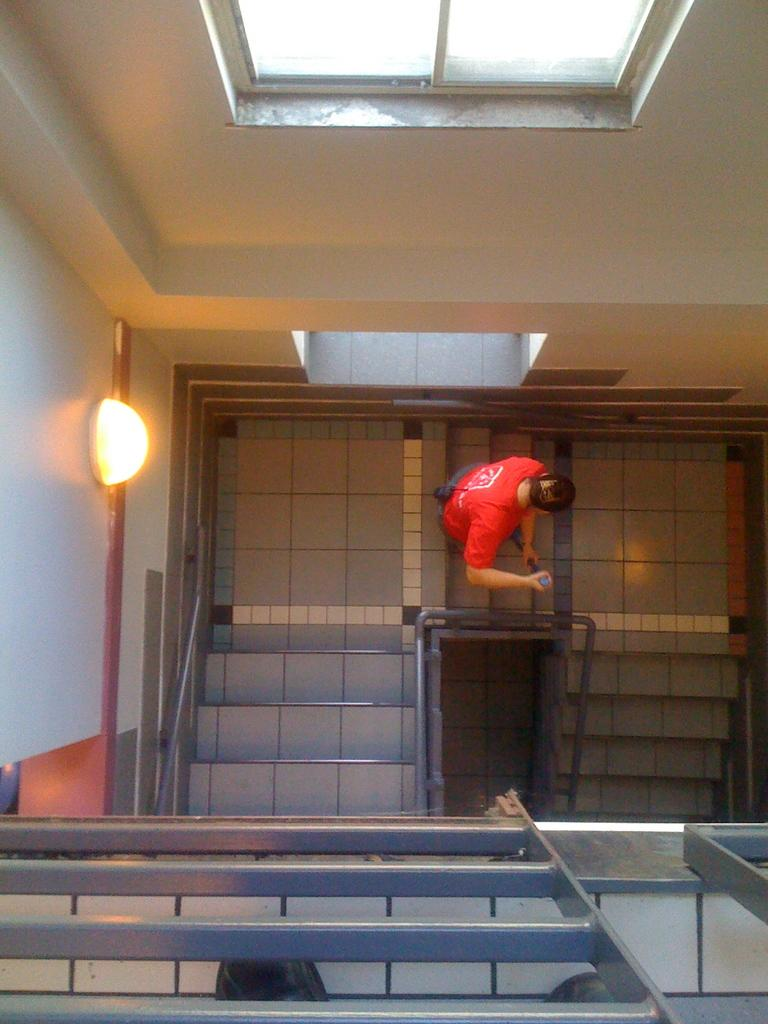What is the main subject of the image? There is a human in the image. What is the human holding in their hands? The human is holding a stick in their hands. What architectural feature can be seen in the image? There are stairs visible in the image. What type of lighting is present in the image? There is a light on the wall in the image. What type of plants can be seen growing near the human in the image? There are no plants visible in the image. What is the kitten doing in the image? There is no kitten present in the image. 